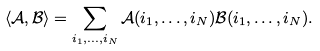Convert formula to latex. <formula><loc_0><loc_0><loc_500><loc_500>\langle \mathcal { A } , \mathcal { B } \rangle = \sum _ { i _ { 1 } , \dots , i _ { N } } \mathcal { A } ( i _ { 1 } , \dots , i _ { N } ) \mathcal { B } ( i _ { 1 } , \dots , i _ { N } ) .</formula> 